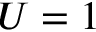<formula> <loc_0><loc_0><loc_500><loc_500>U = 1</formula> 